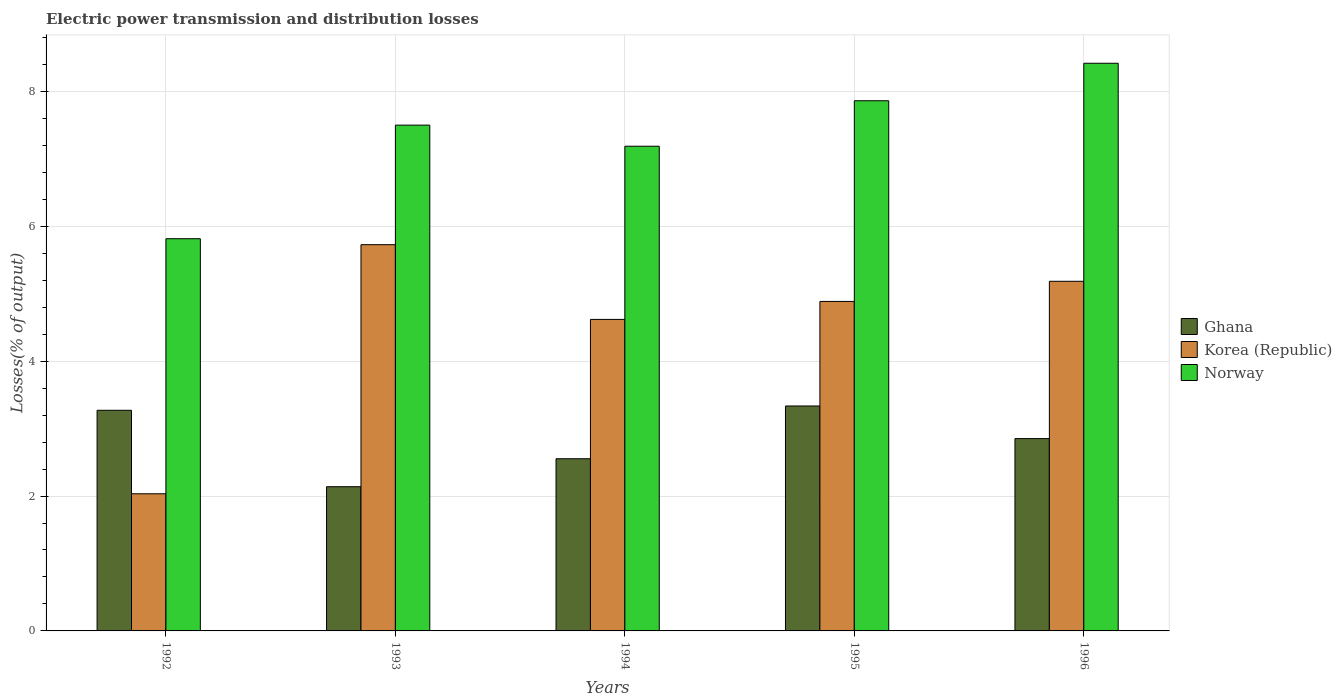How many groups of bars are there?
Provide a short and direct response. 5. Are the number of bars on each tick of the X-axis equal?
Make the answer very short. Yes. How many bars are there on the 4th tick from the left?
Offer a very short reply. 3. How many bars are there on the 4th tick from the right?
Ensure brevity in your answer.  3. What is the label of the 3rd group of bars from the left?
Offer a terse response. 1994. What is the electric power transmission and distribution losses in Ghana in 1995?
Your response must be concise. 3.34. Across all years, what is the maximum electric power transmission and distribution losses in Korea (Republic)?
Provide a succinct answer. 5.73. Across all years, what is the minimum electric power transmission and distribution losses in Korea (Republic)?
Keep it short and to the point. 2.03. In which year was the electric power transmission and distribution losses in Norway maximum?
Make the answer very short. 1996. What is the total electric power transmission and distribution losses in Ghana in the graph?
Your answer should be very brief. 14.15. What is the difference between the electric power transmission and distribution losses in Ghana in 1992 and that in 1996?
Keep it short and to the point. 0.42. What is the difference between the electric power transmission and distribution losses in Ghana in 1993 and the electric power transmission and distribution losses in Korea (Republic) in 1996?
Provide a short and direct response. -3.05. What is the average electric power transmission and distribution losses in Korea (Republic) per year?
Offer a terse response. 4.49. In the year 1992, what is the difference between the electric power transmission and distribution losses in Norway and electric power transmission and distribution losses in Korea (Republic)?
Offer a very short reply. 3.78. In how many years, is the electric power transmission and distribution losses in Ghana greater than 6.4 %?
Keep it short and to the point. 0. What is the ratio of the electric power transmission and distribution losses in Korea (Republic) in 1992 to that in 1996?
Ensure brevity in your answer.  0.39. Is the electric power transmission and distribution losses in Korea (Republic) in 1992 less than that in 1994?
Make the answer very short. Yes. What is the difference between the highest and the second highest electric power transmission and distribution losses in Norway?
Ensure brevity in your answer.  0.56. What is the difference between the highest and the lowest electric power transmission and distribution losses in Norway?
Provide a short and direct response. 2.6. What does the 2nd bar from the right in 1992 represents?
Your response must be concise. Korea (Republic). Is it the case that in every year, the sum of the electric power transmission and distribution losses in Ghana and electric power transmission and distribution losses in Korea (Republic) is greater than the electric power transmission and distribution losses in Norway?
Your answer should be very brief. No. How many bars are there?
Provide a succinct answer. 15. Are all the bars in the graph horizontal?
Provide a short and direct response. No. Are the values on the major ticks of Y-axis written in scientific E-notation?
Your answer should be very brief. No. Does the graph contain any zero values?
Make the answer very short. No. Does the graph contain grids?
Offer a terse response. Yes. What is the title of the graph?
Your answer should be very brief. Electric power transmission and distribution losses. Does "Israel" appear as one of the legend labels in the graph?
Your response must be concise. No. What is the label or title of the Y-axis?
Offer a terse response. Losses(% of output). What is the Losses(% of output) of Ghana in 1992?
Offer a terse response. 3.27. What is the Losses(% of output) of Korea (Republic) in 1992?
Your answer should be very brief. 2.03. What is the Losses(% of output) of Norway in 1992?
Offer a very short reply. 5.82. What is the Losses(% of output) in Ghana in 1993?
Your answer should be very brief. 2.14. What is the Losses(% of output) of Korea (Republic) in 1993?
Your response must be concise. 5.73. What is the Losses(% of output) of Norway in 1993?
Offer a very short reply. 7.5. What is the Losses(% of output) in Ghana in 1994?
Ensure brevity in your answer.  2.55. What is the Losses(% of output) in Korea (Republic) in 1994?
Keep it short and to the point. 4.62. What is the Losses(% of output) in Norway in 1994?
Give a very brief answer. 7.19. What is the Losses(% of output) of Ghana in 1995?
Your response must be concise. 3.34. What is the Losses(% of output) of Korea (Republic) in 1995?
Keep it short and to the point. 4.89. What is the Losses(% of output) of Norway in 1995?
Give a very brief answer. 7.86. What is the Losses(% of output) in Ghana in 1996?
Give a very brief answer. 2.85. What is the Losses(% of output) of Korea (Republic) in 1996?
Offer a terse response. 5.18. What is the Losses(% of output) of Norway in 1996?
Your answer should be very brief. 8.42. Across all years, what is the maximum Losses(% of output) in Ghana?
Your answer should be very brief. 3.34. Across all years, what is the maximum Losses(% of output) of Korea (Republic)?
Your response must be concise. 5.73. Across all years, what is the maximum Losses(% of output) of Norway?
Provide a succinct answer. 8.42. Across all years, what is the minimum Losses(% of output) of Ghana?
Your answer should be very brief. 2.14. Across all years, what is the minimum Losses(% of output) of Korea (Republic)?
Provide a succinct answer. 2.03. Across all years, what is the minimum Losses(% of output) in Norway?
Your answer should be very brief. 5.82. What is the total Losses(% of output) in Ghana in the graph?
Keep it short and to the point. 14.15. What is the total Losses(% of output) of Korea (Republic) in the graph?
Provide a succinct answer. 22.45. What is the total Losses(% of output) of Norway in the graph?
Ensure brevity in your answer.  36.78. What is the difference between the Losses(% of output) of Ghana in 1992 and that in 1993?
Offer a terse response. 1.13. What is the difference between the Losses(% of output) in Korea (Republic) in 1992 and that in 1993?
Give a very brief answer. -3.69. What is the difference between the Losses(% of output) of Norway in 1992 and that in 1993?
Offer a very short reply. -1.68. What is the difference between the Losses(% of output) of Ghana in 1992 and that in 1994?
Provide a succinct answer. 0.72. What is the difference between the Losses(% of output) of Korea (Republic) in 1992 and that in 1994?
Your answer should be very brief. -2.59. What is the difference between the Losses(% of output) of Norway in 1992 and that in 1994?
Ensure brevity in your answer.  -1.37. What is the difference between the Losses(% of output) of Ghana in 1992 and that in 1995?
Give a very brief answer. -0.06. What is the difference between the Losses(% of output) of Korea (Republic) in 1992 and that in 1995?
Ensure brevity in your answer.  -2.85. What is the difference between the Losses(% of output) of Norway in 1992 and that in 1995?
Give a very brief answer. -2.05. What is the difference between the Losses(% of output) of Ghana in 1992 and that in 1996?
Make the answer very short. 0.42. What is the difference between the Losses(% of output) in Korea (Republic) in 1992 and that in 1996?
Give a very brief answer. -3.15. What is the difference between the Losses(% of output) in Norway in 1992 and that in 1996?
Ensure brevity in your answer.  -2.6. What is the difference between the Losses(% of output) of Ghana in 1993 and that in 1994?
Provide a short and direct response. -0.41. What is the difference between the Losses(% of output) in Korea (Republic) in 1993 and that in 1994?
Provide a succinct answer. 1.11. What is the difference between the Losses(% of output) of Norway in 1993 and that in 1994?
Provide a short and direct response. 0.31. What is the difference between the Losses(% of output) in Ghana in 1993 and that in 1995?
Ensure brevity in your answer.  -1.2. What is the difference between the Losses(% of output) in Korea (Republic) in 1993 and that in 1995?
Your answer should be very brief. 0.84. What is the difference between the Losses(% of output) of Norway in 1993 and that in 1995?
Provide a short and direct response. -0.36. What is the difference between the Losses(% of output) of Ghana in 1993 and that in 1996?
Your response must be concise. -0.71. What is the difference between the Losses(% of output) of Korea (Republic) in 1993 and that in 1996?
Keep it short and to the point. 0.54. What is the difference between the Losses(% of output) in Norway in 1993 and that in 1996?
Your response must be concise. -0.92. What is the difference between the Losses(% of output) of Ghana in 1994 and that in 1995?
Make the answer very short. -0.78. What is the difference between the Losses(% of output) in Korea (Republic) in 1994 and that in 1995?
Make the answer very short. -0.27. What is the difference between the Losses(% of output) in Norway in 1994 and that in 1995?
Your response must be concise. -0.67. What is the difference between the Losses(% of output) in Ghana in 1994 and that in 1996?
Give a very brief answer. -0.3. What is the difference between the Losses(% of output) of Korea (Republic) in 1994 and that in 1996?
Ensure brevity in your answer.  -0.57. What is the difference between the Losses(% of output) of Norway in 1994 and that in 1996?
Provide a short and direct response. -1.23. What is the difference between the Losses(% of output) in Ghana in 1995 and that in 1996?
Your answer should be compact. 0.48. What is the difference between the Losses(% of output) in Korea (Republic) in 1995 and that in 1996?
Give a very brief answer. -0.3. What is the difference between the Losses(% of output) of Norway in 1995 and that in 1996?
Give a very brief answer. -0.56. What is the difference between the Losses(% of output) in Ghana in 1992 and the Losses(% of output) in Korea (Republic) in 1993?
Make the answer very short. -2.46. What is the difference between the Losses(% of output) of Ghana in 1992 and the Losses(% of output) of Norway in 1993?
Provide a succinct answer. -4.23. What is the difference between the Losses(% of output) in Korea (Republic) in 1992 and the Losses(% of output) in Norway in 1993?
Your answer should be compact. -5.47. What is the difference between the Losses(% of output) of Ghana in 1992 and the Losses(% of output) of Korea (Republic) in 1994?
Offer a very short reply. -1.35. What is the difference between the Losses(% of output) in Ghana in 1992 and the Losses(% of output) in Norway in 1994?
Give a very brief answer. -3.92. What is the difference between the Losses(% of output) of Korea (Republic) in 1992 and the Losses(% of output) of Norway in 1994?
Provide a succinct answer. -5.15. What is the difference between the Losses(% of output) of Ghana in 1992 and the Losses(% of output) of Korea (Republic) in 1995?
Keep it short and to the point. -1.61. What is the difference between the Losses(% of output) of Ghana in 1992 and the Losses(% of output) of Norway in 1995?
Make the answer very short. -4.59. What is the difference between the Losses(% of output) in Korea (Republic) in 1992 and the Losses(% of output) in Norway in 1995?
Your response must be concise. -5.83. What is the difference between the Losses(% of output) in Ghana in 1992 and the Losses(% of output) in Korea (Republic) in 1996?
Provide a short and direct response. -1.91. What is the difference between the Losses(% of output) in Ghana in 1992 and the Losses(% of output) in Norway in 1996?
Offer a very short reply. -5.15. What is the difference between the Losses(% of output) of Korea (Republic) in 1992 and the Losses(% of output) of Norway in 1996?
Your response must be concise. -6.38. What is the difference between the Losses(% of output) of Ghana in 1993 and the Losses(% of output) of Korea (Republic) in 1994?
Offer a very short reply. -2.48. What is the difference between the Losses(% of output) of Ghana in 1993 and the Losses(% of output) of Norway in 1994?
Give a very brief answer. -5.05. What is the difference between the Losses(% of output) of Korea (Republic) in 1993 and the Losses(% of output) of Norway in 1994?
Keep it short and to the point. -1.46. What is the difference between the Losses(% of output) of Ghana in 1993 and the Losses(% of output) of Korea (Republic) in 1995?
Your response must be concise. -2.75. What is the difference between the Losses(% of output) in Ghana in 1993 and the Losses(% of output) in Norway in 1995?
Provide a succinct answer. -5.72. What is the difference between the Losses(% of output) of Korea (Republic) in 1993 and the Losses(% of output) of Norway in 1995?
Keep it short and to the point. -2.13. What is the difference between the Losses(% of output) of Ghana in 1993 and the Losses(% of output) of Korea (Republic) in 1996?
Make the answer very short. -3.05. What is the difference between the Losses(% of output) of Ghana in 1993 and the Losses(% of output) of Norway in 1996?
Provide a short and direct response. -6.28. What is the difference between the Losses(% of output) in Korea (Republic) in 1993 and the Losses(% of output) in Norway in 1996?
Provide a short and direct response. -2.69. What is the difference between the Losses(% of output) in Ghana in 1994 and the Losses(% of output) in Korea (Republic) in 1995?
Provide a succinct answer. -2.33. What is the difference between the Losses(% of output) in Ghana in 1994 and the Losses(% of output) in Norway in 1995?
Offer a very short reply. -5.31. What is the difference between the Losses(% of output) in Korea (Republic) in 1994 and the Losses(% of output) in Norway in 1995?
Offer a terse response. -3.24. What is the difference between the Losses(% of output) of Ghana in 1994 and the Losses(% of output) of Korea (Republic) in 1996?
Provide a succinct answer. -2.63. What is the difference between the Losses(% of output) of Ghana in 1994 and the Losses(% of output) of Norway in 1996?
Keep it short and to the point. -5.86. What is the difference between the Losses(% of output) in Korea (Republic) in 1994 and the Losses(% of output) in Norway in 1996?
Your answer should be compact. -3.8. What is the difference between the Losses(% of output) of Ghana in 1995 and the Losses(% of output) of Korea (Republic) in 1996?
Provide a succinct answer. -1.85. What is the difference between the Losses(% of output) of Ghana in 1995 and the Losses(% of output) of Norway in 1996?
Provide a succinct answer. -5.08. What is the difference between the Losses(% of output) in Korea (Republic) in 1995 and the Losses(% of output) in Norway in 1996?
Give a very brief answer. -3.53. What is the average Losses(% of output) of Ghana per year?
Offer a very short reply. 2.83. What is the average Losses(% of output) of Korea (Republic) per year?
Provide a succinct answer. 4.49. What is the average Losses(% of output) of Norway per year?
Give a very brief answer. 7.36. In the year 1992, what is the difference between the Losses(% of output) in Ghana and Losses(% of output) in Korea (Republic)?
Your response must be concise. 1.24. In the year 1992, what is the difference between the Losses(% of output) of Ghana and Losses(% of output) of Norway?
Your answer should be compact. -2.54. In the year 1992, what is the difference between the Losses(% of output) of Korea (Republic) and Losses(% of output) of Norway?
Make the answer very short. -3.78. In the year 1993, what is the difference between the Losses(% of output) of Ghana and Losses(% of output) of Korea (Republic)?
Offer a very short reply. -3.59. In the year 1993, what is the difference between the Losses(% of output) of Ghana and Losses(% of output) of Norway?
Offer a very short reply. -5.36. In the year 1993, what is the difference between the Losses(% of output) of Korea (Republic) and Losses(% of output) of Norway?
Offer a terse response. -1.77. In the year 1994, what is the difference between the Losses(% of output) of Ghana and Losses(% of output) of Korea (Republic)?
Provide a short and direct response. -2.07. In the year 1994, what is the difference between the Losses(% of output) in Ghana and Losses(% of output) in Norway?
Provide a short and direct response. -4.63. In the year 1994, what is the difference between the Losses(% of output) of Korea (Republic) and Losses(% of output) of Norway?
Keep it short and to the point. -2.57. In the year 1995, what is the difference between the Losses(% of output) of Ghana and Losses(% of output) of Korea (Republic)?
Offer a terse response. -1.55. In the year 1995, what is the difference between the Losses(% of output) in Ghana and Losses(% of output) in Norway?
Make the answer very short. -4.53. In the year 1995, what is the difference between the Losses(% of output) of Korea (Republic) and Losses(% of output) of Norway?
Provide a succinct answer. -2.98. In the year 1996, what is the difference between the Losses(% of output) of Ghana and Losses(% of output) of Korea (Republic)?
Your answer should be very brief. -2.33. In the year 1996, what is the difference between the Losses(% of output) of Ghana and Losses(% of output) of Norway?
Provide a short and direct response. -5.57. In the year 1996, what is the difference between the Losses(% of output) of Korea (Republic) and Losses(% of output) of Norway?
Keep it short and to the point. -3.23. What is the ratio of the Losses(% of output) in Ghana in 1992 to that in 1993?
Provide a succinct answer. 1.53. What is the ratio of the Losses(% of output) of Korea (Republic) in 1992 to that in 1993?
Provide a succinct answer. 0.36. What is the ratio of the Losses(% of output) in Norway in 1992 to that in 1993?
Provide a succinct answer. 0.78. What is the ratio of the Losses(% of output) in Ghana in 1992 to that in 1994?
Your response must be concise. 1.28. What is the ratio of the Losses(% of output) in Korea (Republic) in 1992 to that in 1994?
Provide a succinct answer. 0.44. What is the ratio of the Losses(% of output) of Norway in 1992 to that in 1994?
Your answer should be compact. 0.81. What is the ratio of the Losses(% of output) of Ghana in 1992 to that in 1995?
Give a very brief answer. 0.98. What is the ratio of the Losses(% of output) of Korea (Republic) in 1992 to that in 1995?
Provide a short and direct response. 0.42. What is the ratio of the Losses(% of output) of Norway in 1992 to that in 1995?
Your answer should be compact. 0.74. What is the ratio of the Losses(% of output) in Ghana in 1992 to that in 1996?
Make the answer very short. 1.15. What is the ratio of the Losses(% of output) of Korea (Republic) in 1992 to that in 1996?
Provide a succinct answer. 0.39. What is the ratio of the Losses(% of output) in Norway in 1992 to that in 1996?
Keep it short and to the point. 0.69. What is the ratio of the Losses(% of output) in Ghana in 1993 to that in 1994?
Make the answer very short. 0.84. What is the ratio of the Losses(% of output) in Korea (Republic) in 1993 to that in 1994?
Offer a very short reply. 1.24. What is the ratio of the Losses(% of output) of Norway in 1993 to that in 1994?
Your response must be concise. 1.04. What is the ratio of the Losses(% of output) in Ghana in 1993 to that in 1995?
Offer a terse response. 0.64. What is the ratio of the Losses(% of output) of Korea (Republic) in 1993 to that in 1995?
Offer a very short reply. 1.17. What is the ratio of the Losses(% of output) of Norway in 1993 to that in 1995?
Keep it short and to the point. 0.95. What is the ratio of the Losses(% of output) in Ghana in 1993 to that in 1996?
Offer a terse response. 0.75. What is the ratio of the Losses(% of output) of Korea (Republic) in 1993 to that in 1996?
Your response must be concise. 1.1. What is the ratio of the Losses(% of output) of Norway in 1993 to that in 1996?
Provide a succinct answer. 0.89. What is the ratio of the Losses(% of output) of Ghana in 1994 to that in 1995?
Your answer should be compact. 0.77. What is the ratio of the Losses(% of output) of Korea (Republic) in 1994 to that in 1995?
Your response must be concise. 0.95. What is the ratio of the Losses(% of output) of Norway in 1994 to that in 1995?
Give a very brief answer. 0.91. What is the ratio of the Losses(% of output) in Ghana in 1994 to that in 1996?
Offer a very short reply. 0.9. What is the ratio of the Losses(% of output) in Korea (Republic) in 1994 to that in 1996?
Ensure brevity in your answer.  0.89. What is the ratio of the Losses(% of output) in Norway in 1994 to that in 1996?
Offer a terse response. 0.85. What is the ratio of the Losses(% of output) in Ghana in 1995 to that in 1996?
Keep it short and to the point. 1.17. What is the ratio of the Losses(% of output) in Korea (Republic) in 1995 to that in 1996?
Provide a short and direct response. 0.94. What is the ratio of the Losses(% of output) in Norway in 1995 to that in 1996?
Ensure brevity in your answer.  0.93. What is the difference between the highest and the second highest Losses(% of output) of Ghana?
Make the answer very short. 0.06. What is the difference between the highest and the second highest Losses(% of output) of Korea (Republic)?
Your response must be concise. 0.54. What is the difference between the highest and the second highest Losses(% of output) of Norway?
Offer a terse response. 0.56. What is the difference between the highest and the lowest Losses(% of output) in Ghana?
Ensure brevity in your answer.  1.2. What is the difference between the highest and the lowest Losses(% of output) in Korea (Republic)?
Ensure brevity in your answer.  3.69. What is the difference between the highest and the lowest Losses(% of output) in Norway?
Offer a terse response. 2.6. 